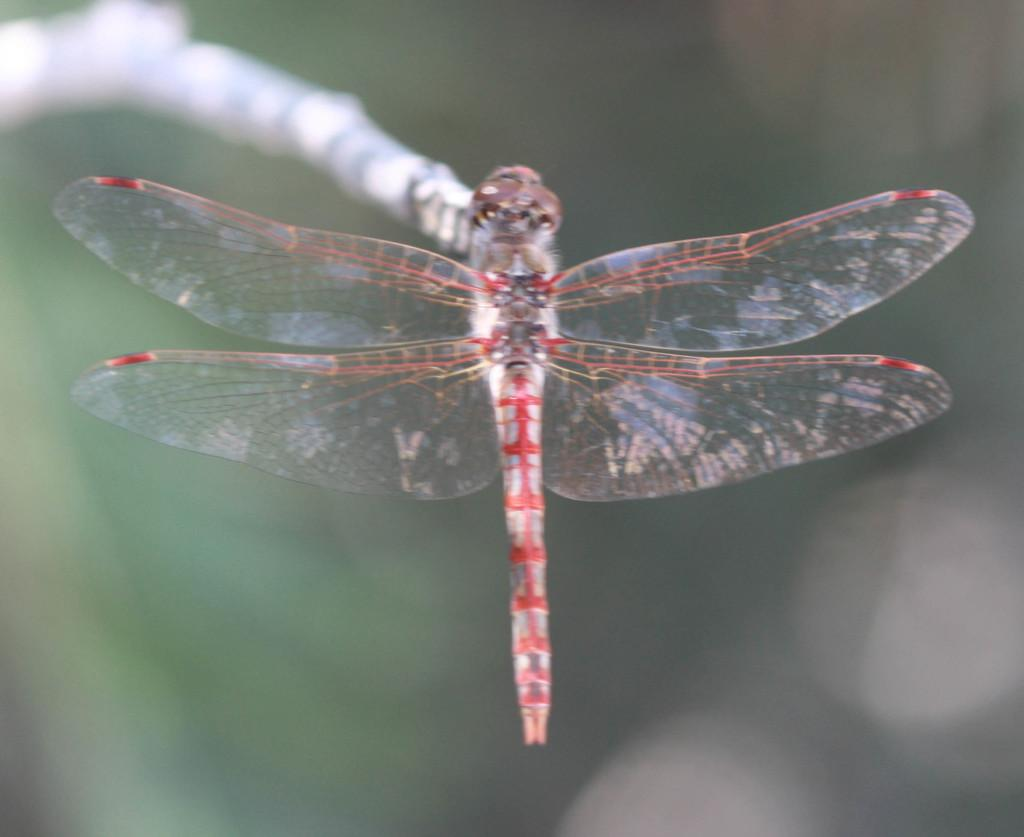What is the main subject of the picture? The main subject of the picture is a dragonfly. Where is the dragonfly located in the image? The dragonfly is on a branch. Can you describe the background of the image? The background of the image is blurry. What type of scale can be seen in the image? There is no scale present in the image; it features a dragonfly on a branch with a blurry background. Are there any snails visible in the image? There are no snails present in the image; it features a dragonfly on a branch with a blurry background. 